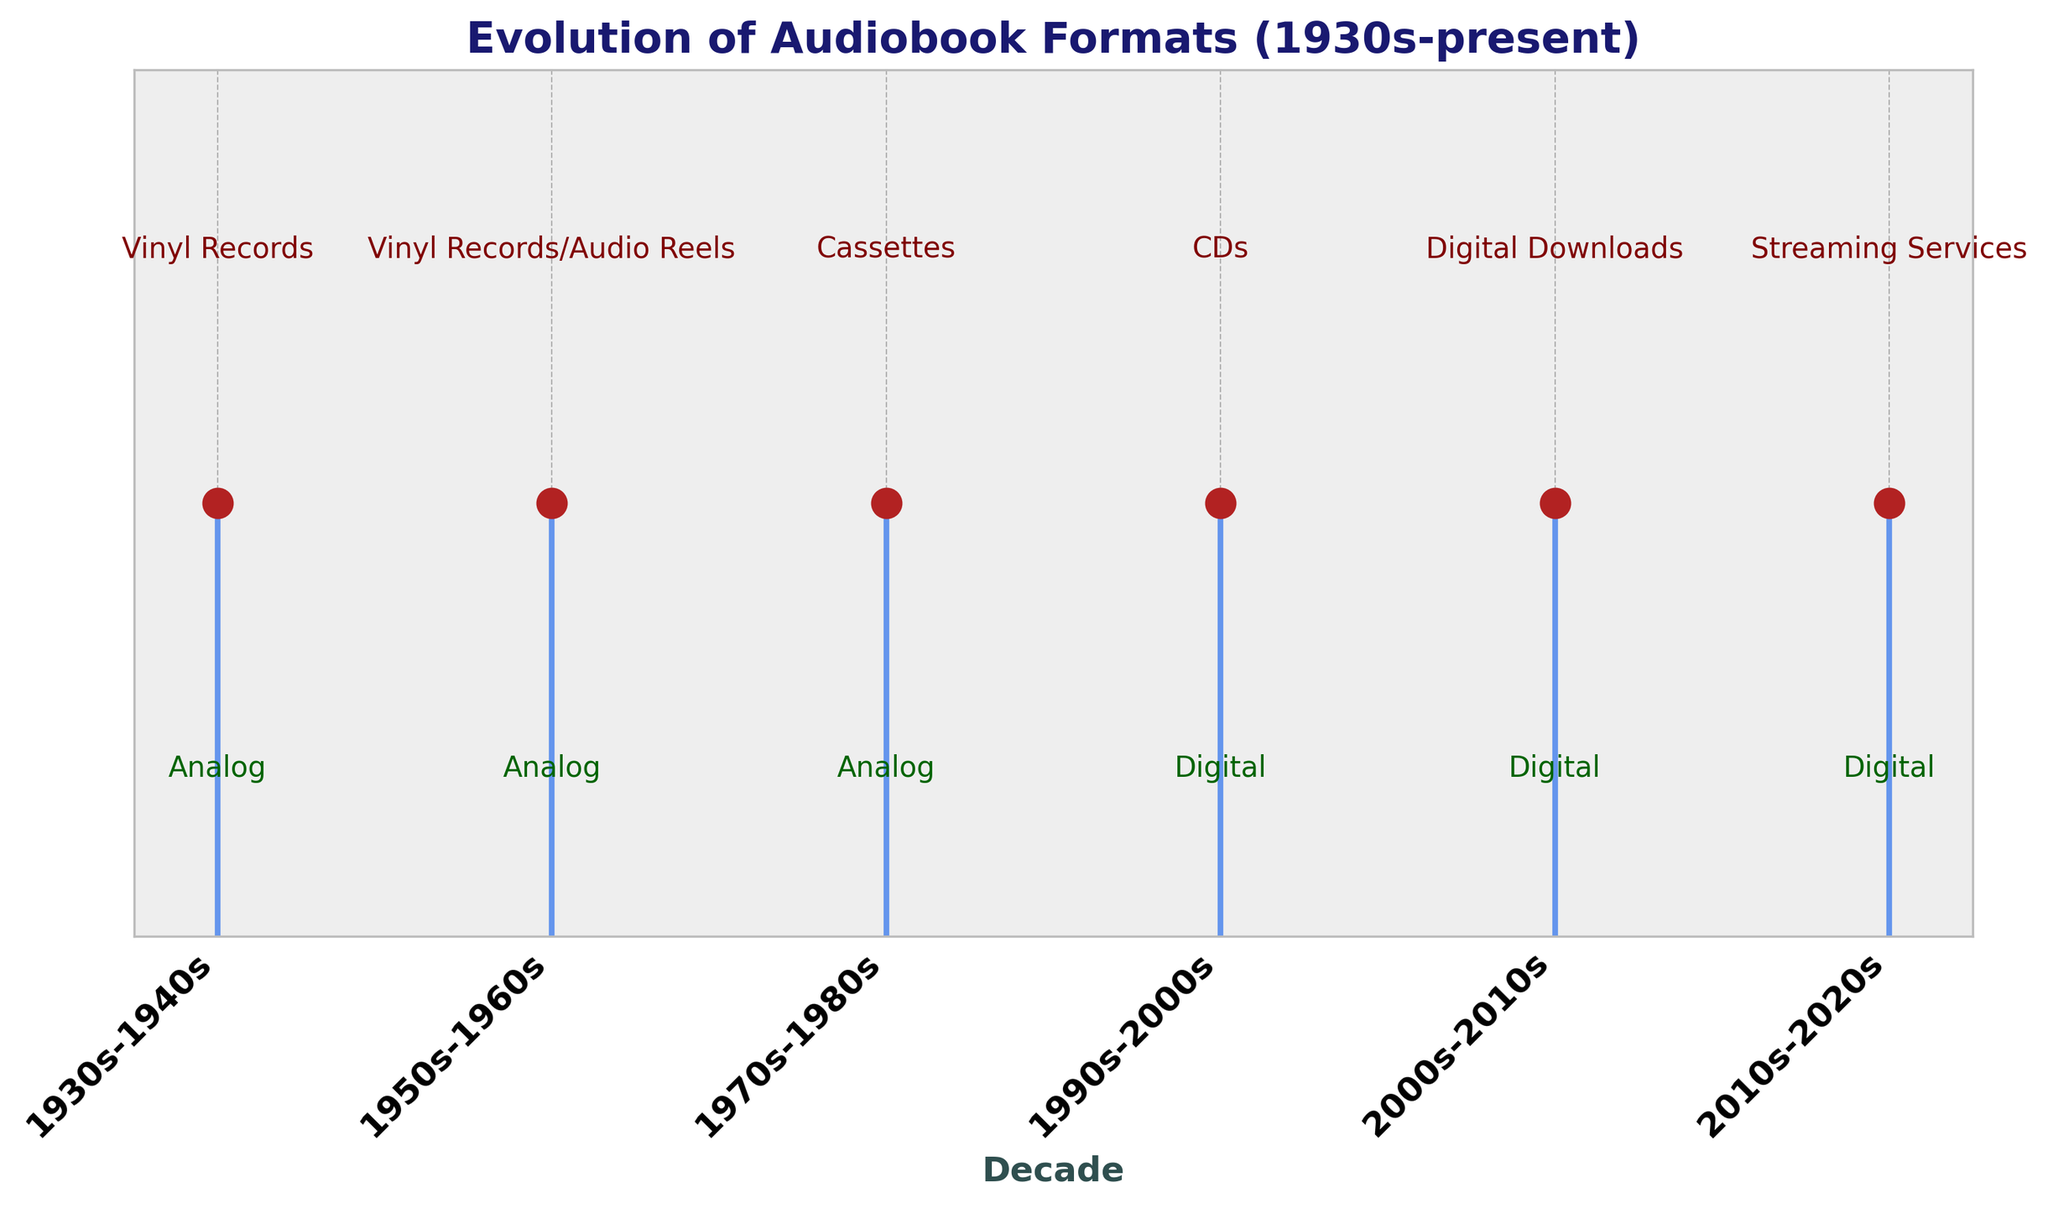What decade first introduced digital technology for audiobooks? The figure shows a timeline of audiobook formats and technology, marking the transition from analog to digital in the 1990s-2000s, which introduced CDs.
Answer: 1990s-2000s Which format lasted the longest based on the figure? Vinyl Records are shown to have been dominant from the 1930s-1960s, covering three decades. Other formats cover fewer decades.
Answer: Vinyl Records How many distinct formats appear on the figure? Observing the figure, Vinyl Records, Audio Reels, Cassettes, CDs, Digital Downloads, and Streaming Services appear, totaling six distinct formats.
Answer: 6 What is the most recent format illustrated in the figure? The last format in the timeline is labeled "Streaming Services," marking the 2010s-2020s period.
Answer: Streaming Services Which format marked the transition from analog to digital technology? According to the figure, the transition occurred in the 1990s-2000s, with CDs being the dominant format, marking the shift from analog to digital.
Answer: CDs How does the visual height of the labels for Vinyl Records and Streaming Services compare on the plot? The visual height of labels indicates prominence within their timeframes. Vinyl Records' label is higher up during the 1930s-1960s than Streaming Services' label in the 2010s-2020s, also indicating their starting points closer to the top.
Answer: Higher Which formats share the same timeframe according to the figure? The figure shows that during the 1950s-1960s, both Vinyl Records and Audio Reels were prominent.
Answer: Vinyl Records and Audio Reels Which technology had the shortest representation time on the plot? Audio Reels, only visible for the 1950s-1960s, had the shortest representation time, compared to other technologies spanning longer periods.
Answer: Audio Reels How many decades have digital technologies been dominant according to the plot? From the plot, digital technologies (CDs, Digital Downloads, Streaming Services) span from the 1990s to the 2020s, covering four decades.
Answer: 4 